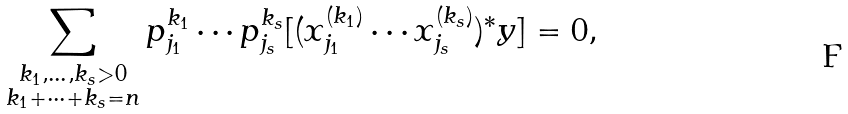Convert formula to latex. <formula><loc_0><loc_0><loc_500><loc_500>\sum _ { \substack { k _ { 1 } , \dots , k _ { s } > 0 \\ k _ { 1 } + \cdots + k _ { s } = n } } p _ { j _ { 1 } } ^ { k _ { 1 } } \cdots p _ { j _ { s } } ^ { k _ { s } } [ ( x _ { j _ { 1 } } ^ { ( k _ { 1 } ) } \cdots x _ { j _ { s } } ^ { ( k _ { s } ) } ) ^ { \ast } y ] = 0 ,</formula> 